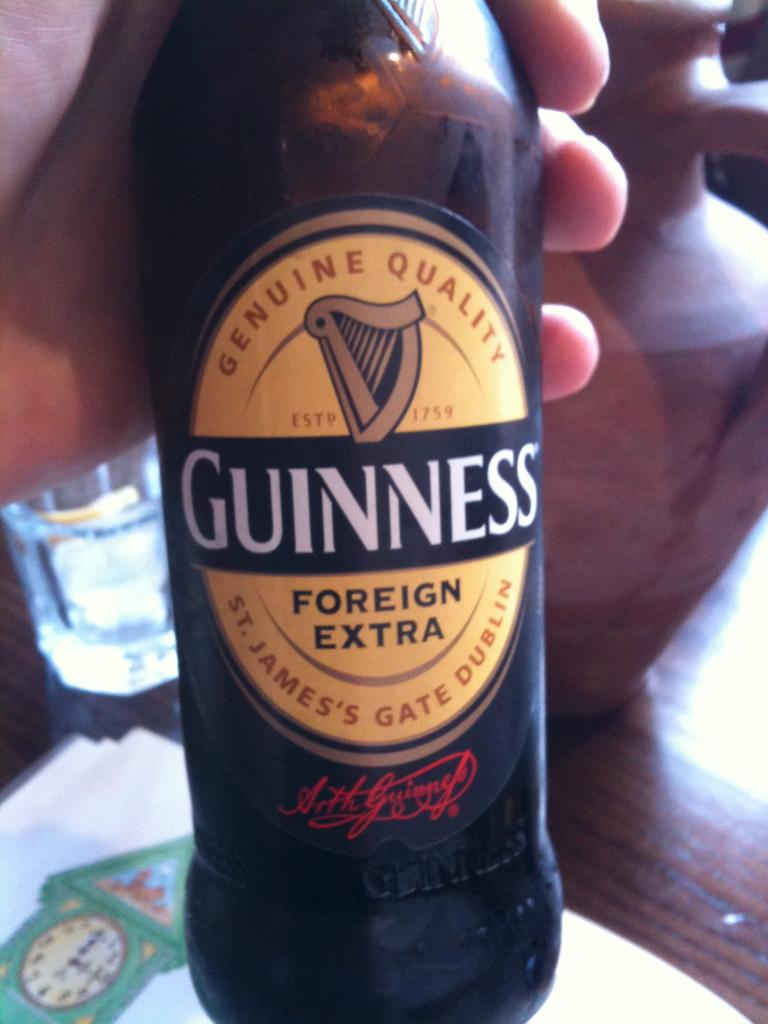<image>
Write a terse but informative summary of the picture. A genuine bottle of Foreign Extra Guinness beer. 